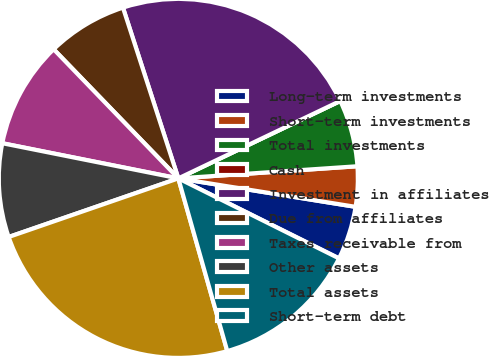Convert chart to OTSL. <chart><loc_0><loc_0><loc_500><loc_500><pie_chart><fcel>Long-term investments<fcel>Short-term investments<fcel>Total investments<fcel>Cash<fcel>Investment in affiliates<fcel>Due from affiliates<fcel>Taxes receivable from<fcel>Other assets<fcel>Total assets<fcel>Short-term debt<nl><fcel>4.82%<fcel>3.61%<fcel>6.02%<fcel>0.0%<fcel>22.89%<fcel>7.23%<fcel>9.64%<fcel>8.43%<fcel>24.1%<fcel>13.25%<nl></chart> 